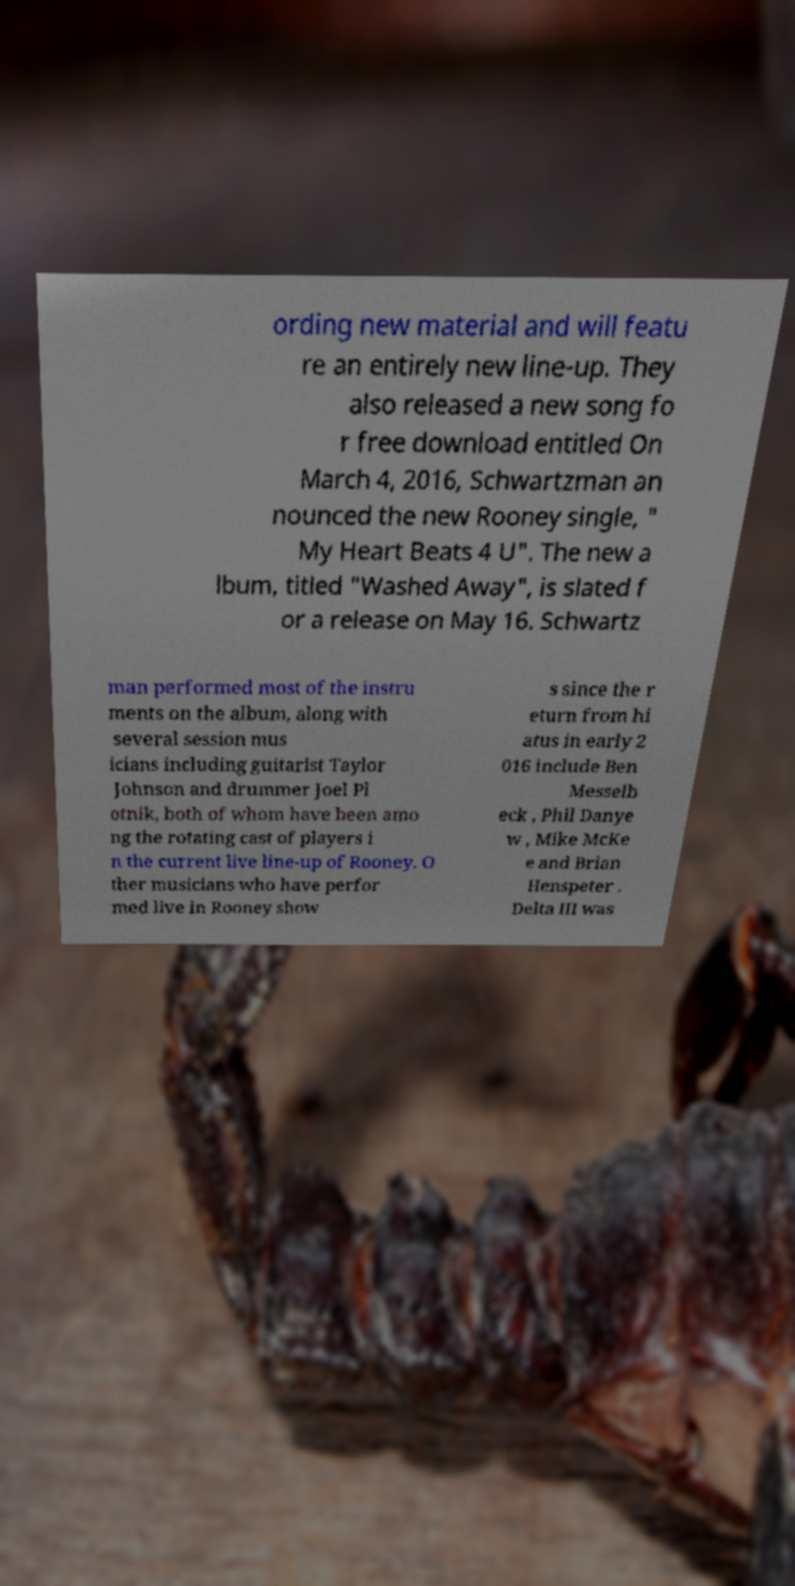I need the written content from this picture converted into text. Can you do that? ording new material and will featu re an entirely new line-up. They also released a new song fo r free download entitled On March 4, 2016, Schwartzman an nounced the new Rooney single, " My Heart Beats 4 U". The new a lbum, titled "Washed Away", is slated f or a release on May 16. Schwartz man performed most of the instru ments on the album, along with several session mus icians including guitarist Taylor Johnson and drummer Joel Pl otnik, both of whom have been amo ng the rotating cast of players i n the current live line-up of Rooney. O ther musicians who have perfor med live in Rooney show s since the r eturn from hi atus in early 2 016 include Ben Messelb eck , Phil Danye w , Mike McKe e and Brian Henspeter . Delta III was 